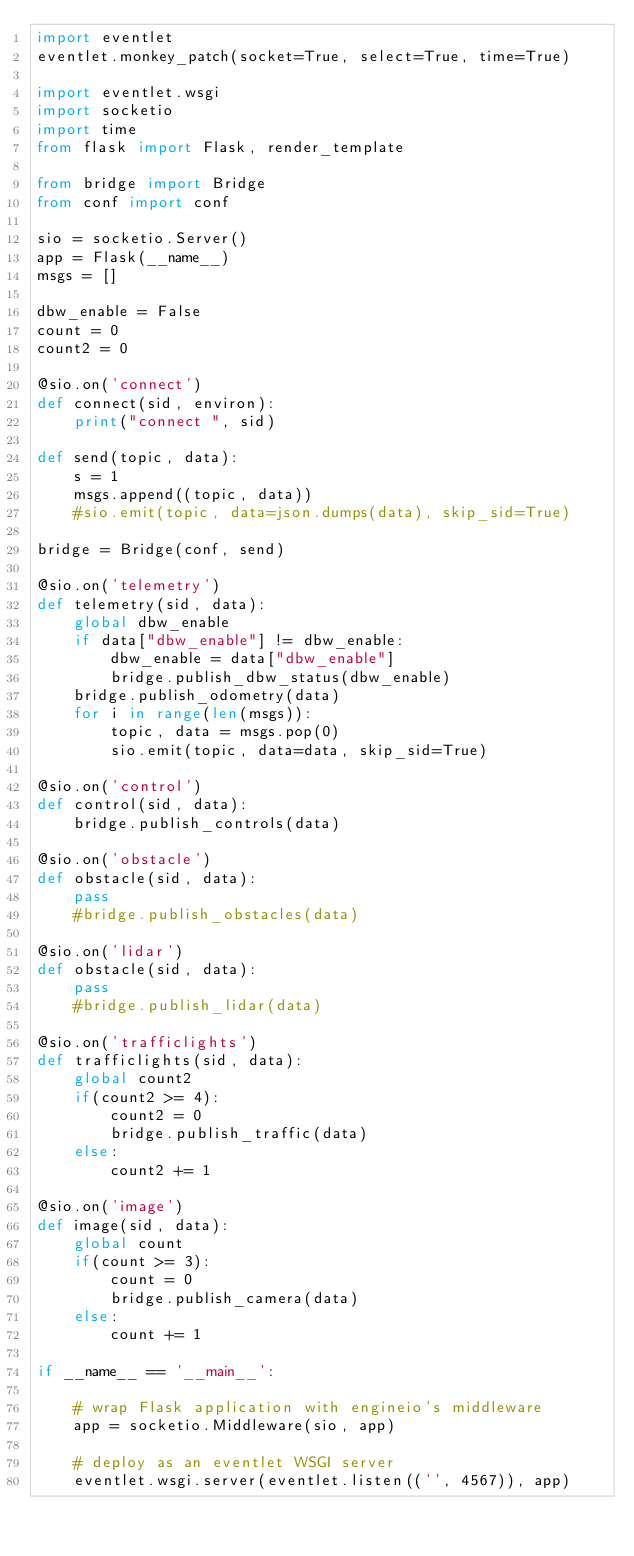<code> <loc_0><loc_0><loc_500><loc_500><_Python_>import eventlet
eventlet.monkey_patch(socket=True, select=True, time=True)

import eventlet.wsgi
import socketio
import time
from flask import Flask, render_template

from bridge import Bridge
from conf import conf

sio = socketio.Server()
app = Flask(__name__)
msgs = []

dbw_enable = False
count = 0
count2 = 0

@sio.on('connect')
def connect(sid, environ):
    print("connect ", sid)

def send(topic, data):
    s = 1
    msgs.append((topic, data))
    #sio.emit(topic, data=json.dumps(data), skip_sid=True)

bridge = Bridge(conf, send)

@sio.on('telemetry')
def telemetry(sid, data):
    global dbw_enable
    if data["dbw_enable"] != dbw_enable:
        dbw_enable = data["dbw_enable"]
        bridge.publish_dbw_status(dbw_enable)
    bridge.publish_odometry(data)
    for i in range(len(msgs)):
        topic, data = msgs.pop(0)
        sio.emit(topic, data=data, skip_sid=True)

@sio.on('control')
def control(sid, data):
    bridge.publish_controls(data)

@sio.on('obstacle')
def obstacle(sid, data):
    pass
    #bridge.publish_obstacles(data)

@sio.on('lidar')
def obstacle(sid, data):
    pass
    #bridge.publish_lidar(data)

@sio.on('trafficlights')
def trafficlights(sid, data):
    global count2
    if(count2 >= 4):
        count2 = 0
        bridge.publish_traffic(data)
    else:
        count2 += 1

@sio.on('image')
def image(sid, data):
    global count
    if(count >= 3):
        count = 0
        bridge.publish_camera(data)
    else:
        count += 1

if __name__ == '__main__':

    # wrap Flask application with engineio's middleware
    app = socketio.Middleware(sio, app)

    # deploy as an eventlet WSGI server
    eventlet.wsgi.server(eventlet.listen(('', 4567)), app)
</code> 